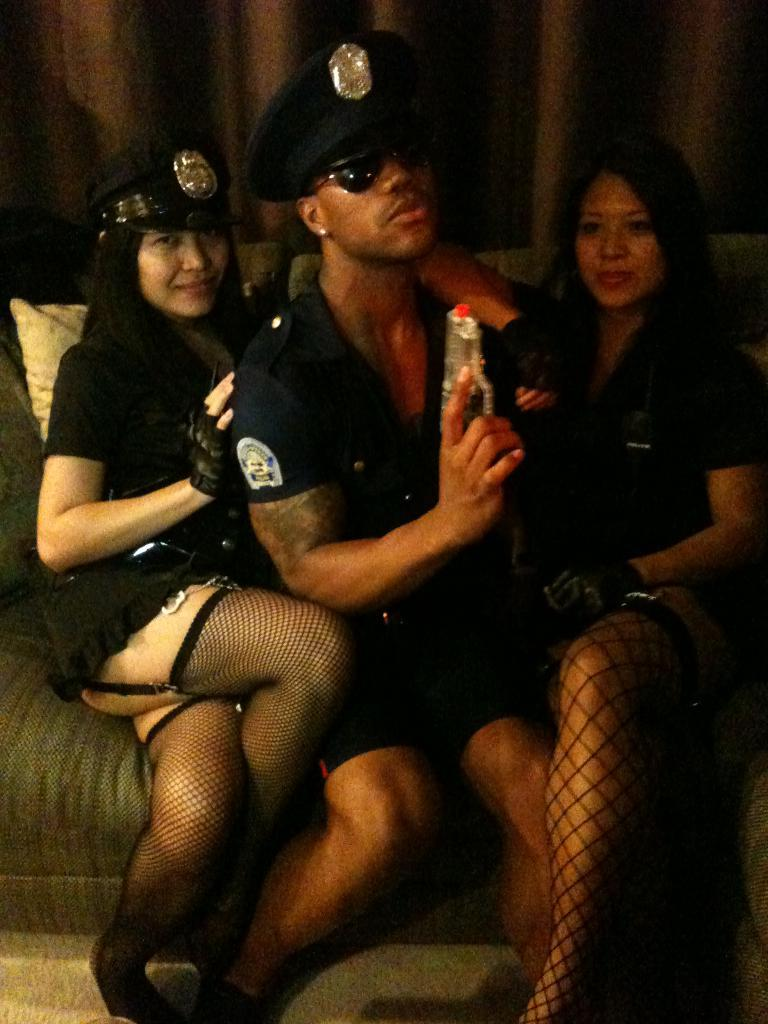How many people are in the image? There are three people in the image: one man and two women. What are the people in the image doing? The man and women are sitting on a couch. What can be seen in the background of the image? There are curtains hanging in the background of the image. What type of industry is depicted in the image? There is no industry depicted in the image; it features a man and two women sitting on a couch. What is the value of the camera used to take the image? There is no camera mentioned or visible in the image, so it is impossible to determine the value of any camera used to take the image. 